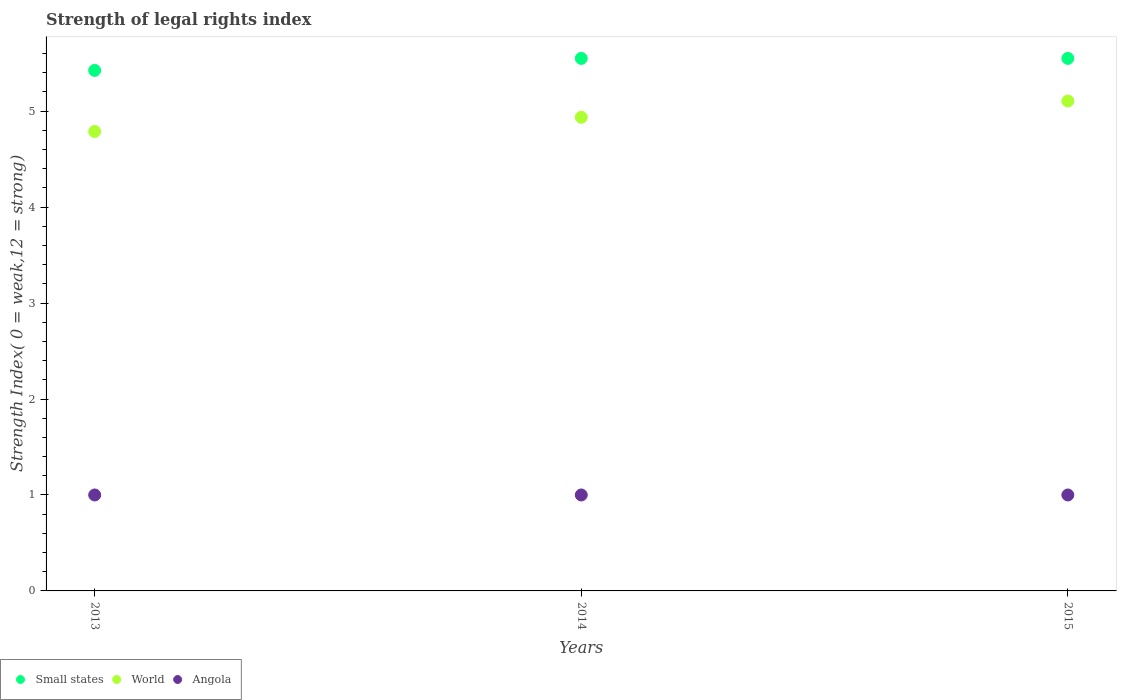How many different coloured dotlines are there?
Provide a short and direct response. 3. What is the strength index in World in 2015?
Provide a succinct answer. 5.11. Across all years, what is the maximum strength index in Angola?
Offer a terse response. 1. Across all years, what is the minimum strength index in Angola?
Give a very brief answer. 1. In which year was the strength index in Angola maximum?
Your answer should be very brief. 2013. In which year was the strength index in Angola minimum?
Give a very brief answer. 2013. What is the total strength index in Small states in the graph?
Your answer should be compact. 16.52. What is the difference between the strength index in Angola in 2013 and the strength index in Small states in 2014?
Keep it short and to the point. -4.55. What is the average strength index in World per year?
Provide a short and direct response. 4.94. In the year 2013, what is the difference between the strength index in World and strength index in Small states?
Your answer should be compact. -0.64. Is the strength index in Small states in 2013 less than that in 2015?
Provide a succinct answer. Yes. What is the difference between the highest and the second highest strength index in World?
Offer a terse response. 0.17. What is the difference between the highest and the lowest strength index in Small states?
Make the answer very short. 0.12. Is the sum of the strength index in Small states in 2013 and 2014 greater than the maximum strength index in World across all years?
Your answer should be very brief. Yes. Is it the case that in every year, the sum of the strength index in Angola and strength index in World  is greater than the strength index in Small states?
Offer a terse response. Yes. How many dotlines are there?
Provide a succinct answer. 3. Does the graph contain grids?
Give a very brief answer. No. Where does the legend appear in the graph?
Provide a short and direct response. Bottom left. How many legend labels are there?
Give a very brief answer. 3. What is the title of the graph?
Give a very brief answer. Strength of legal rights index. What is the label or title of the X-axis?
Your response must be concise. Years. What is the label or title of the Y-axis?
Give a very brief answer. Strength Index( 0 = weak,12 = strong). What is the Strength Index( 0 = weak,12 = strong) in Small states in 2013?
Offer a terse response. 5.42. What is the Strength Index( 0 = weak,12 = strong) of World in 2013?
Make the answer very short. 4.79. What is the Strength Index( 0 = weak,12 = strong) in Angola in 2013?
Keep it short and to the point. 1. What is the Strength Index( 0 = weak,12 = strong) in Small states in 2014?
Offer a terse response. 5.55. What is the Strength Index( 0 = weak,12 = strong) of World in 2014?
Keep it short and to the point. 4.94. What is the Strength Index( 0 = weak,12 = strong) in Angola in 2014?
Provide a succinct answer. 1. What is the Strength Index( 0 = weak,12 = strong) in Small states in 2015?
Your answer should be compact. 5.55. What is the Strength Index( 0 = weak,12 = strong) in World in 2015?
Your response must be concise. 5.11. What is the Strength Index( 0 = weak,12 = strong) in Angola in 2015?
Keep it short and to the point. 1. Across all years, what is the maximum Strength Index( 0 = weak,12 = strong) of Small states?
Provide a succinct answer. 5.55. Across all years, what is the maximum Strength Index( 0 = weak,12 = strong) in World?
Provide a short and direct response. 5.11. Across all years, what is the minimum Strength Index( 0 = weak,12 = strong) of Small states?
Give a very brief answer. 5.42. Across all years, what is the minimum Strength Index( 0 = weak,12 = strong) of World?
Offer a terse response. 4.79. What is the total Strength Index( 0 = weak,12 = strong) of Small states in the graph?
Offer a very short reply. 16.52. What is the total Strength Index( 0 = weak,12 = strong) of World in the graph?
Your response must be concise. 14.83. What is the difference between the Strength Index( 0 = weak,12 = strong) of Small states in 2013 and that in 2014?
Your response must be concise. -0.12. What is the difference between the Strength Index( 0 = weak,12 = strong) in World in 2013 and that in 2014?
Provide a short and direct response. -0.15. What is the difference between the Strength Index( 0 = weak,12 = strong) of Small states in 2013 and that in 2015?
Provide a succinct answer. -0.12. What is the difference between the Strength Index( 0 = weak,12 = strong) of World in 2013 and that in 2015?
Provide a succinct answer. -0.32. What is the difference between the Strength Index( 0 = weak,12 = strong) of Angola in 2013 and that in 2015?
Offer a terse response. 0. What is the difference between the Strength Index( 0 = weak,12 = strong) of World in 2014 and that in 2015?
Your answer should be compact. -0.17. What is the difference between the Strength Index( 0 = weak,12 = strong) of Angola in 2014 and that in 2015?
Ensure brevity in your answer.  0. What is the difference between the Strength Index( 0 = weak,12 = strong) of Small states in 2013 and the Strength Index( 0 = weak,12 = strong) of World in 2014?
Give a very brief answer. 0.49. What is the difference between the Strength Index( 0 = weak,12 = strong) in Small states in 2013 and the Strength Index( 0 = weak,12 = strong) in Angola in 2014?
Your response must be concise. 4.42. What is the difference between the Strength Index( 0 = weak,12 = strong) in World in 2013 and the Strength Index( 0 = weak,12 = strong) in Angola in 2014?
Give a very brief answer. 3.79. What is the difference between the Strength Index( 0 = weak,12 = strong) in Small states in 2013 and the Strength Index( 0 = weak,12 = strong) in World in 2015?
Provide a succinct answer. 0.32. What is the difference between the Strength Index( 0 = weak,12 = strong) in Small states in 2013 and the Strength Index( 0 = weak,12 = strong) in Angola in 2015?
Ensure brevity in your answer.  4.42. What is the difference between the Strength Index( 0 = weak,12 = strong) in World in 2013 and the Strength Index( 0 = weak,12 = strong) in Angola in 2015?
Your answer should be very brief. 3.79. What is the difference between the Strength Index( 0 = weak,12 = strong) of Small states in 2014 and the Strength Index( 0 = weak,12 = strong) of World in 2015?
Give a very brief answer. 0.44. What is the difference between the Strength Index( 0 = weak,12 = strong) of Small states in 2014 and the Strength Index( 0 = weak,12 = strong) of Angola in 2015?
Provide a short and direct response. 4.55. What is the difference between the Strength Index( 0 = weak,12 = strong) in World in 2014 and the Strength Index( 0 = weak,12 = strong) in Angola in 2015?
Your response must be concise. 3.94. What is the average Strength Index( 0 = weak,12 = strong) in Small states per year?
Your response must be concise. 5.51. What is the average Strength Index( 0 = weak,12 = strong) in World per year?
Provide a succinct answer. 4.94. What is the average Strength Index( 0 = weak,12 = strong) in Angola per year?
Your answer should be compact. 1. In the year 2013, what is the difference between the Strength Index( 0 = weak,12 = strong) of Small states and Strength Index( 0 = weak,12 = strong) of World?
Your answer should be compact. 0.64. In the year 2013, what is the difference between the Strength Index( 0 = weak,12 = strong) of Small states and Strength Index( 0 = weak,12 = strong) of Angola?
Your answer should be very brief. 4.42. In the year 2013, what is the difference between the Strength Index( 0 = weak,12 = strong) in World and Strength Index( 0 = weak,12 = strong) in Angola?
Make the answer very short. 3.79. In the year 2014, what is the difference between the Strength Index( 0 = weak,12 = strong) of Small states and Strength Index( 0 = weak,12 = strong) of World?
Your answer should be very brief. 0.61. In the year 2014, what is the difference between the Strength Index( 0 = weak,12 = strong) of Small states and Strength Index( 0 = weak,12 = strong) of Angola?
Offer a very short reply. 4.55. In the year 2014, what is the difference between the Strength Index( 0 = weak,12 = strong) in World and Strength Index( 0 = weak,12 = strong) in Angola?
Provide a succinct answer. 3.94. In the year 2015, what is the difference between the Strength Index( 0 = weak,12 = strong) of Small states and Strength Index( 0 = weak,12 = strong) of World?
Make the answer very short. 0.44. In the year 2015, what is the difference between the Strength Index( 0 = weak,12 = strong) of Small states and Strength Index( 0 = weak,12 = strong) of Angola?
Ensure brevity in your answer.  4.55. In the year 2015, what is the difference between the Strength Index( 0 = weak,12 = strong) of World and Strength Index( 0 = weak,12 = strong) of Angola?
Keep it short and to the point. 4.11. What is the ratio of the Strength Index( 0 = weak,12 = strong) in Small states in 2013 to that in 2014?
Offer a very short reply. 0.98. What is the ratio of the Strength Index( 0 = weak,12 = strong) of World in 2013 to that in 2014?
Ensure brevity in your answer.  0.97. What is the ratio of the Strength Index( 0 = weak,12 = strong) of Small states in 2013 to that in 2015?
Ensure brevity in your answer.  0.98. What is the ratio of the Strength Index( 0 = weak,12 = strong) in World in 2013 to that in 2015?
Offer a very short reply. 0.94. What is the ratio of the Strength Index( 0 = weak,12 = strong) of World in 2014 to that in 2015?
Your answer should be compact. 0.97. What is the ratio of the Strength Index( 0 = weak,12 = strong) in Angola in 2014 to that in 2015?
Your response must be concise. 1. What is the difference between the highest and the second highest Strength Index( 0 = weak,12 = strong) of Small states?
Ensure brevity in your answer.  0. What is the difference between the highest and the second highest Strength Index( 0 = weak,12 = strong) in World?
Ensure brevity in your answer.  0.17. What is the difference between the highest and the second highest Strength Index( 0 = weak,12 = strong) of Angola?
Make the answer very short. 0. What is the difference between the highest and the lowest Strength Index( 0 = weak,12 = strong) of Small states?
Your response must be concise. 0.12. What is the difference between the highest and the lowest Strength Index( 0 = weak,12 = strong) of World?
Keep it short and to the point. 0.32. 